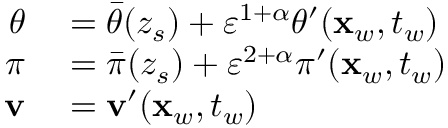<formula> <loc_0><loc_0><loc_500><loc_500>\begin{array} { r l } { \theta } & = \bar { \theta } ( z _ { s } ) + { \varepsilon } ^ { 1 + \alpha } \theta ^ { \prime } ( x _ { w } , t _ { w } ) } \\ { \pi } & = \bar { \pi } ( z _ { s } ) + { \varepsilon } ^ { 2 + \alpha } \pi ^ { \prime } ( x _ { w } , t _ { w } ) } \\ { v } & = v ^ { \prime } ( x _ { w } , t _ { w } ) } \end{array}</formula> 